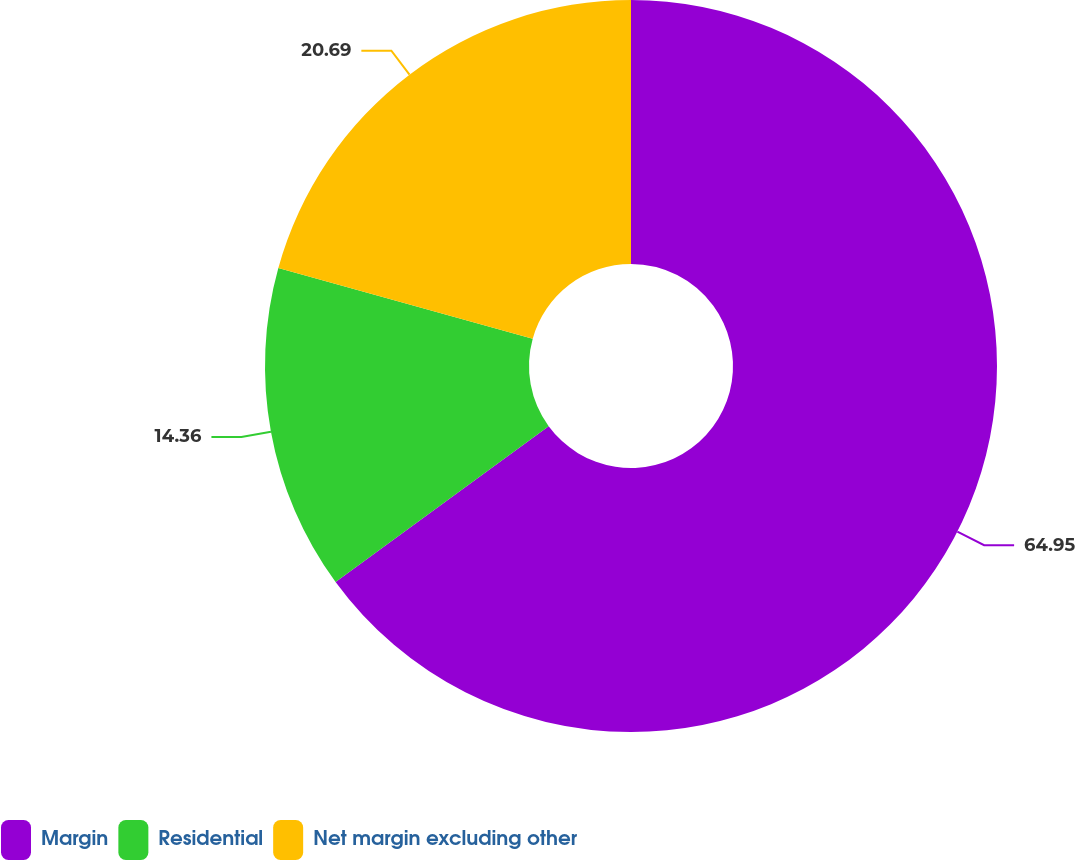<chart> <loc_0><loc_0><loc_500><loc_500><pie_chart><fcel>Margin<fcel>Residential<fcel>Net margin excluding other<nl><fcel>64.95%<fcel>14.36%<fcel>20.69%<nl></chart> 